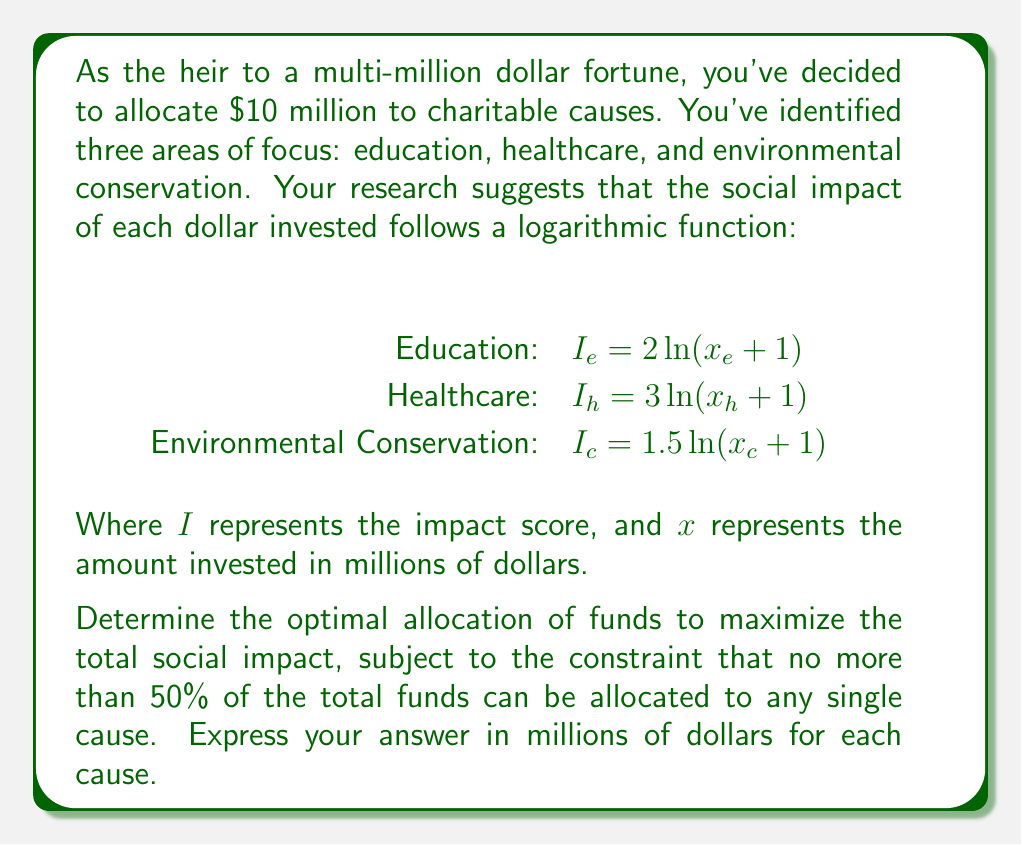Help me with this question. To solve this optimization problem, we'll use the method of Lagrange multipliers with inequality constraints. Let's approach this step-by-step:

1) First, we define our objective function:

   $f(x_e, x_h, x_c) = 2\ln(x_e + 1) + 3\ln(x_h + 1) + 1.5\ln(x_c + 1)$

2) Our constraints are:

   $g_1(x_e, x_h, x_c) = x_e + x_h + x_c - 10 = 0$ (total budget constraint)
   $g_2(x_e) = x_e - 5 \leq 0$
   $g_3(x_h) = x_h - 5 \leq 0$
   $g_4(x_c) = x_c - 5 \leq 0$
   $x_e, x_h, x_c \geq 0$

3) We form the Lagrangian:

   $L = f + \lambda_1 g_1 + \lambda_2 g_2 + \lambda_3 g_3 + \lambda_4 g_4$

4) The KKT conditions give us:

   $\frac{\partial L}{\partial x_e} = \frac{2}{x_e + 1} + \lambda_1 + \lambda_2 = 0$
   $\frac{\partial L}{\partial x_h} = \frac{3}{x_h + 1} + \lambda_1 + \lambda_3 = 0$
   $\frac{\partial L}{\partial x_c} = \frac{1.5}{x_c + 1} + \lambda_1 + \lambda_4 = 0$

   $\lambda_2(x_e - 5) = 0$, $\lambda_3(x_h - 5) = 0$, $\lambda_4(x_c - 5) = 0$
   $\lambda_2, \lambda_3, \lambda_4 \geq 0$

5) From these conditions, we can deduce that:

   $\frac{2}{x_e + 1} = \frac{3}{x_h + 1} = \frac{1.5}{x_c + 1} - \lambda_2 = -\lambda_1$

6) This implies that $x_h > x_e > x_c$. Given the budget constraint and the 50% limit, we can conclude that $x_h = 5$.

7) Substituting this back into our equations:

   $\frac{2}{x_e + 1} = \frac{3}{6} = 0.5$
   $\frac{1.5}{x_c + 1} = 0.5$

8) Solving these:

   $x_e = 3$
   $x_c = 2$

Therefore, the optimal allocation is:
Healthcare: $5 million
Education: $3 million
Environmental Conservation: $2 million
Answer: Healthcare: $5 million
Education: $3 million
Environmental Conservation: $2 million 